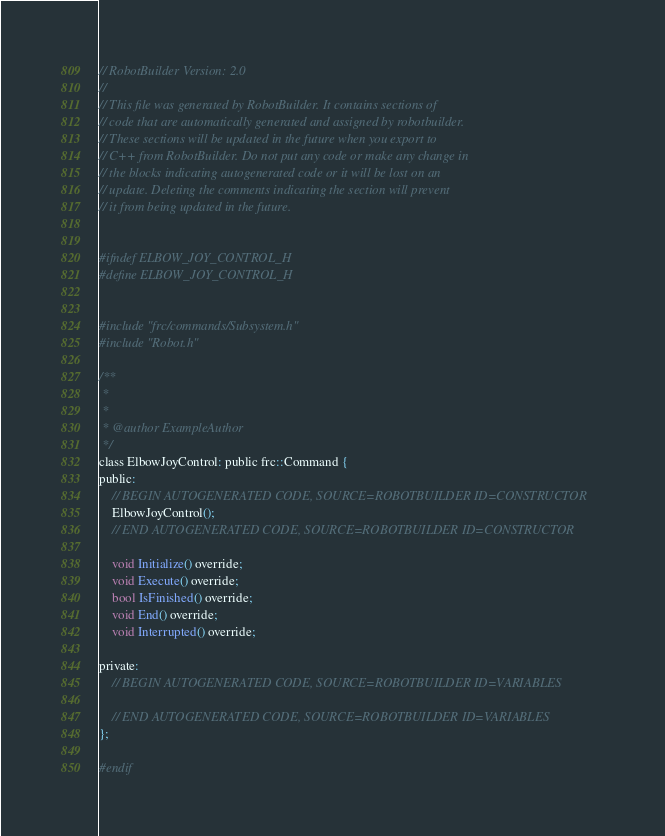Convert code to text. <code><loc_0><loc_0><loc_500><loc_500><_C_>// RobotBuilder Version: 2.0
//
// This file was generated by RobotBuilder. It contains sections of
// code that are automatically generated and assigned by robotbuilder.
// These sections will be updated in the future when you export to
// C++ from RobotBuilder. Do not put any code or make any change in
// the blocks indicating autogenerated code or it will be lost on an
// update. Deleting the comments indicating the section will prevent
// it from being updated in the future.


#ifndef ELBOW_JOY_CONTROL_H
#define ELBOW_JOY_CONTROL_H


#include "frc/commands/Subsystem.h"
#include "Robot.h"

/**
 *
 *
 * @author ExampleAuthor
 */
class ElbowJoyControl: public frc::Command {
public:
    // BEGIN AUTOGENERATED CODE, SOURCE=ROBOTBUILDER ID=CONSTRUCTOR
	ElbowJoyControl();
    // END AUTOGENERATED CODE, SOURCE=ROBOTBUILDER ID=CONSTRUCTOR

	void Initialize() override;
	void Execute() override;
	bool IsFinished() override;
	void End() override;
	void Interrupted() override;

private:
	// BEGIN AUTOGENERATED CODE, SOURCE=ROBOTBUILDER ID=VARIABLES

	// END AUTOGENERATED CODE, SOURCE=ROBOTBUILDER ID=VARIABLES
};

#endif
</code> 